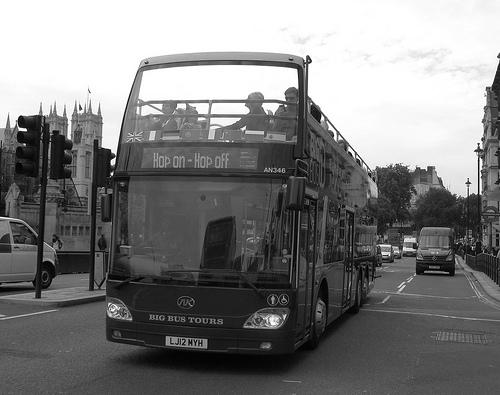Question: what is the picture showing?
Choices:
A. A tour bus.
B. A limosuine.
C. A taxi cab.
D. A dump truck.
Answer with the letter. Answer: A Question: when was the picture taken?
Choices:
A. Very early morning.
B. During the day.
C. Dusk.
D. At night.
Answer with the letter. Answer: B Question: what does the monitor read on the bus?
Choices:
A. Hop on - hop off.
B. All stops.
C. Downtown.
D. On time.
Answer with the letter. Answer: A 